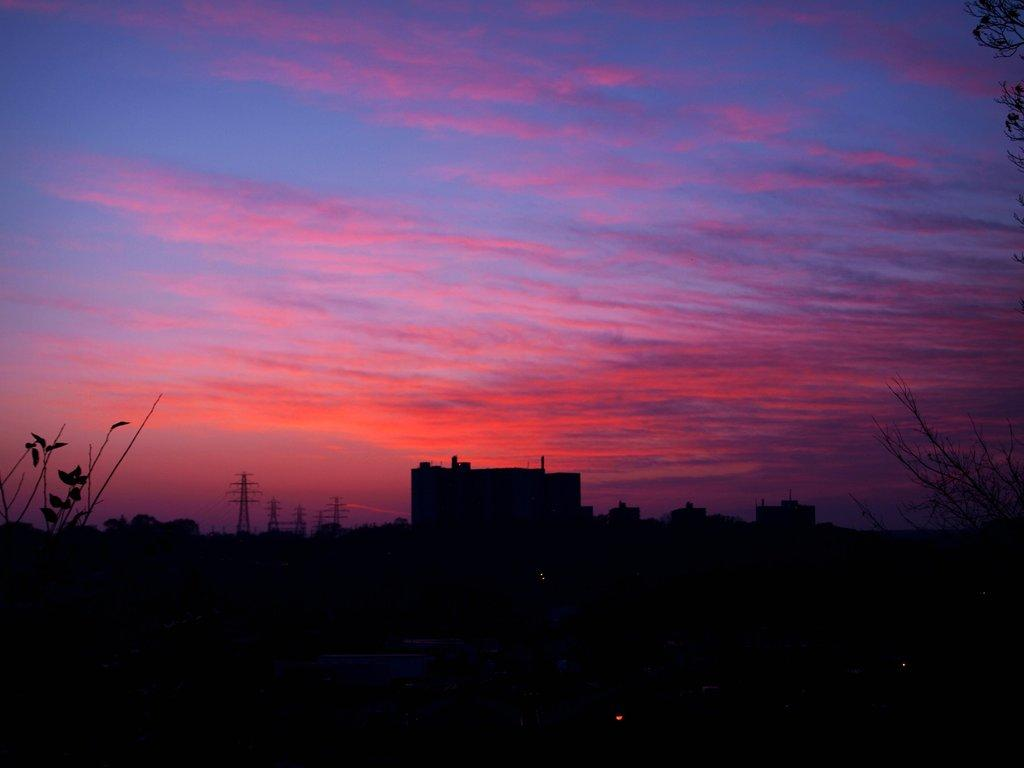What type of natural elements can be seen in the image? There are trees in the image. What type of man-made structures are present in the image? There are structures that resemble buildings in the image. What type of communication infrastructure can be seen in the image? There are cell towers in the image. What is visible in the background of the image? The sky is visible in the background of the image. What type of arithmetic problem is being solved on the chalkboard in the image? There is no chalkboard or arithmetic problem present in the image. 